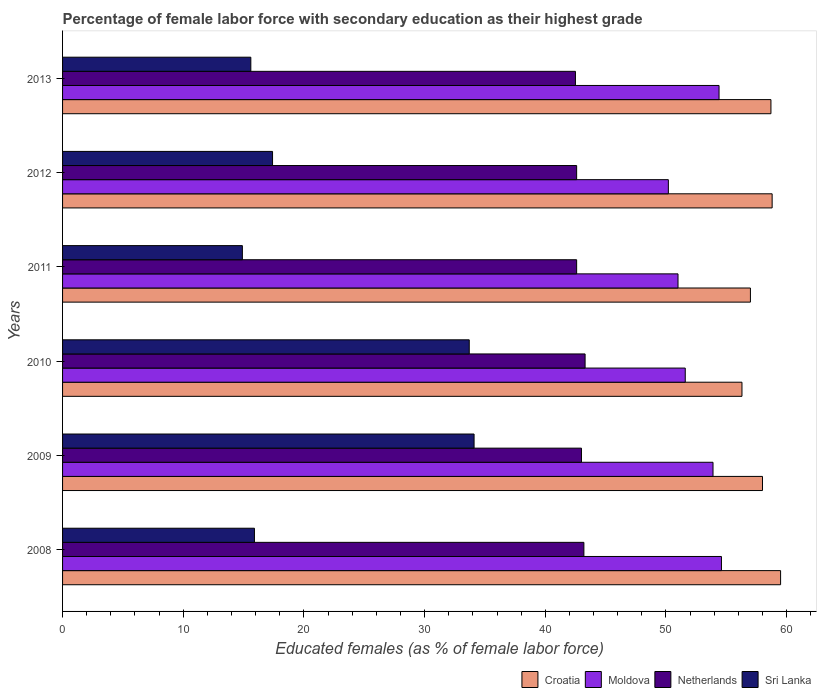Are the number of bars per tick equal to the number of legend labels?
Offer a terse response. Yes. How many bars are there on the 3rd tick from the bottom?
Provide a succinct answer. 4. In how many cases, is the number of bars for a given year not equal to the number of legend labels?
Make the answer very short. 0. What is the percentage of female labor force with secondary education in Croatia in 2013?
Ensure brevity in your answer.  58.7. Across all years, what is the maximum percentage of female labor force with secondary education in Croatia?
Offer a very short reply. 59.5. Across all years, what is the minimum percentage of female labor force with secondary education in Sri Lanka?
Your response must be concise. 14.9. In which year was the percentage of female labor force with secondary education in Sri Lanka maximum?
Offer a very short reply. 2009. In which year was the percentage of female labor force with secondary education in Sri Lanka minimum?
Ensure brevity in your answer.  2011. What is the total percentage of female labor force with secondary education in Moldova in the graph?
Your response must be concise. 315.7. What is the difference between the percentage of female labor force with secondary education in Sri Lanka in 2010 and that in 2012?
Provide a succinct answer. 16.3. What is the difference between the percentage of female labor force with secondary education in Sri Lanka in 2009 and the percentage of female labor force with secondary education in Netherlands in 2012?
Offer a terse response. -8.5. What is the average percentage of female labor force with secondary education in Sri Lanka per year?
Your response must be concise. 21.93. In the year 2010, what is the difference between the percentage of female labor force with secondary education in Moldova and percentage of female labor force with secondary education in Croatia?
Offer a very short reply. -4.7. In how many years, is the percentage of female labor force with secondary education in Moldova greater than 8 %?
Your answer should be compact. 6. What is the ratio of the percentage of female labor force with secondary education in Croatia in 2009 to that in 2011?
Ensure brevity in your answer.  1.02. Is the percentage of female labor force with secondary education in Netherlands in 2008 less than that in 2010?
Give a very brief answer. Yes. What is the difference between the highest and the second highest percentage of female labor force with secondary education in Netherlands?
Ensure brevity in your answer.  0.1. What is the difference between the highest and the lowest percentage of female labor force with secondary education in Moldova?
Your response must be concise. 4.4. Is the sum of the percentage of female labor force with secondary education in Moldova in 2012 and 2013 greater than the maximum percentage of female labor force with secondary education in Netherlands across all years?
Your answer should be compact. Yes. What does the 4th bar from the top in 2012 represents?
Your response must be concise. Croatia. What does the 4th bar from the bottom in 2013 represents?
Offer a very short reply. Sri Lanka. Are all the bars in the graph horizontal?
Offer a terse response. Yes. Are the values on the major ticks of X-axis written in scientific E-notation?
Your response must be concise. No. How many legend labels are there?
Ensure brevity in your answer.  4. What is the title of the graph?
Offer a very short reply. Percentage of female labor force with secondary education as their highest grade. Does "Palau" appear as one of the legend labels in the graph?
Keep it short and to the point. No. What is the label or title of the X-axis?
Offer a very short reply. Educated females (as % of female labor force). What is the label or title of the Y-axis?
Ensure brevity in your answer.  Years. What is the Educated females (as % of female labor force) of Croatia in 2008?
Make the answer very short. 59.5. What is the Educated females (as % of female labor force) of Moldova in 2008?
Offer a terse response. 54.6. What is the Educated females (as % of female labor force) of Netherlands in 2008?
Provide a short and direct response. 43.2. What is the Educated females (as % of female labor force) in Sri Lanka in 2008?
Offer a terse response. 15.9. What is the Educated females (as % of female labor force) of Moldova in 2009?
Provide a short and direct response. 53.9. What is the Educated females (as % of female labor force) in Netherlands in 2009?
Offer a very short reply. 43. What is the Educated females (as % of female labor force) in Sri Lanka in 2009?
Your response must be concise. 34.1. What is the Educated females (as % of female labor force) of Croatia in 2010?
Provide a short and direct response. 56.3. What is the Educated females (as % of female labor force) in Moldova in 2010?
Provide a succinct answer. 51.6. What is the Educated females (as % of female labor force) of Netherlands in 2010?
Make the answer very short. 43.3. What is the Educated females (as % of female labor force) of Sri Lanka in 2010?
Ensure brevity in your answer.  33.7. What is the Educated females (as % of female labor force) of Moldova in 2011?
Ensure brevity in your answer.  51. What is the Educated females (as % of female labor force) in Netherlands in 2011?
Give a very brief answer. 42.6. What is the Educated females (as % of female labor force) of Sri Lanka in 2011?
Offer a terse response. 14.9. What is the Educated females (as % of female labor force) of Croatia in 2012?
Your answer should be compact. 58.8. What is the Educated females (as % of female labor force) of Moldova in 2012?
Ensure brevity in your answer.  50.2. What is the Educated females (as % of female labor force) of Netherlands in 2012?
Provide a short and direct response. 42.6. What is the Educated females (as % of female labor force) of Sri Lanka in 2012?
Offer a terse response. 17.4. What is the Educated females (as % of female labor force) of Croatia in 2013?
Make the answer very short. 58.7. What is the Educated females (as % of female labor force) in Moldova in 2013?
Your answer should be compact. 54.4. What is the Educated females (as % of female labor force) in Netherlands in 2013?
Your response must be concise. 42.5. What is the Educated females (as % of female labor force) in Sri Lanka in 2013?
Offer a terse response. 15.6. Across all years, what is the maximum Educated females (as % of female labor force) in Croatia?
Make the answer very short. 59.5. Across all years, what is the maximum Educated females (as % of female labor force) in Moldova?
Keep it short and to the point. 54.6. Across all years, what is the maximum Educated females (as % of female labor force) in Netherlands?
Your response must be concise. 43.3. Across all years, what is the maximum Educated females (as % of female labor force) of Sri Lanka?
Your answer should be very brief. 34.1. Across all years, what is the minimum Educated females (as % of female labor force) of Croatia?
Your answer should be compact. 56.3. Across all years, what is the minimum Educated females (as % of female labor force) in Moldova?
Give a very brief answer. 50.2. Across all years, what is the minimum Educated females (as % of female labor force) in Netherlands?
Provide a succinct answer. 42.5. Across all years, what is the minimum Educated females (as % of female labor force) in Sri Lanka?
Your response must be concise. 14.9. What is the total Educated females (as % of female labor force) in Croatia in the graph?
Make the answer very short. 348.3. What is the total Educated females (as % of female labor force) in Moldova in the graph?
Provide a succinct answer. 315.7. What is the total Educated females (as % of female labor force) in Netherlands in the graph?
Keep it short and to the point. 257.2. What is the total Educated females (as % of female labor force) in Sri Lanka in the graph?
Give a very brief answer. 131.6. What is the difference between the Educated females (as % of female labor force) of Moldova in 2008 and that in 2009?
Your answer should be very brief. 0.7. What is the difference between the Educated females (as % of female labor force) of Sri Lanka in 2008 and that in 2009?
Your answer should be very brief. -18.2. What is the difference between the Educated females (as % of female labor force) of Croatia in 2008 and that in 2010?
Make the answer very short. 3.2. What is the difference between the Educated females (as % of female labor force) of Sri Lanka in 2008 and that in 2010?
Your answer should be compact. -17.8. What is the difference between the Educated females (as % of female labor force) in Croatia in 2008 and that in 2011?
Give a very brief answer. 2.5. What is the difference between the Educated females (as % of female labor force) of Moldova in 2008 and that in 2011?
Your answer should be very brief. 3.6. What is the difference between the Educated females (as % of female labor force) of Sri Lanka in 2008 and that in 2011?
Offer a terse response. 1. What is the difference between the Educated females (as % of female labor force) of Netherlands in 2008 and that in 2012?
Your answer should be compact. 0.6. What is the difference between the Educated females (as % of female labor force) in Moldova in 2008 and that in 2013?
Give a very brief answer. 0.2. What is the difference between the Educated females (as % of female labor force) in Netherlands in 2008 and that in 2013?
Make the answer very short. 0.7. What is the difference between the Educated females (as % of female labor force) of Croatia in 2009 and that in 2010?
Give a very brief answer. 1.7. What is the difference between the Educated females (as % of female labor force) in Sri Lanka in 2009 and that in 2010?
Your answer should be very brief. 0.4. What is the difference between the Educated females (as % of female labor force) in Croatia in 2009 and that in 2011?
Keep it short and to the point. 1. What is the difference between the Educated females (as % of female labor force) of Netherlands in 2009 and that in 2011?
Make the answer very short. 0.4. What is the difference between the Educated females (as % of female labor force) of Sri Lanka in 2009 and that in 2011?
Offer a terse response. 19.2. What is the difference between the Educated females (as % of female labor force) of Croatia in 2009 and that in 2012?
Provide a succinct answer. -0.8. What is the difference between the Educated females (as % of female labor force) in Netherlands in 2009 and that in 2012?
Make the answer very short. 0.4. What is the difference between the Educated females (as % of female labor force) in Sri Lanka in 2009 and that in 2012?
Offer a terse response. 16.7. What is the difference between the Educated females (as % of female labor force) of Croatia in 2009 and that in 2013?
Your answer should be very brief. -0.7. What is the difference between the Educated females (as % of female labor force) in Sri Lanka in 2009 and that in 2013?
Your answer should be compact. 18.5. What is the difference between the Educated females (as % of female labor force) in Croatia in 2010 and that in 2011?
Your answer should be very brief. -0.7. What is the difference between the Educated females (as % of female labor force) of Sri Lanka in 2010 and that in 2011?
Keep it short and to the point. 18.8. What is the difference between the Educated females (as % of female labor force) of Croatia in 2010 and that in 2012?
Your response must be concise. -2.5. What is the difference between the Educated females (as % of female labor force) in Moldova in 2010 and that in 2012?
Provide a succinct answer. 1.4. What is the difference between the Educated females (as % of female labor force) in Moldova in 2010 and that in 2013?
Your response must be concise. -2.8. What is the difference between the Educated females (as % of female labor force) in Croatia in 2011 and that in 2012?
Provide a short and direct response. -1.8. What is the difference between the Educated females (as % of female labor force) of Moldova in 2011 and that in 2012?
Your answer should be very brief. 0.8. What is the difference between the Educated females (as % of female labor force) in Netherlands in 2011 and that in 2012?
Provide a succinct answer. 0. What is the difference between the Educated females (as % of female labor force) in Sri Lanka in 2011 and that in 2012?
Give a very brief answer. -2.5. What is the difference between the Educated females (as % of female labor force) of Moldova in 2011 and that in 2013?
Provide a succinct answer. -3.4. What is the difference between the Educated females (as % of female labor force) of Netherlands in 2011 and that in 2013?
Provide a short and direct response. 0.1. What is the difference between the Educated females (as % of female labor force) of Sri Lanka in 2011 and that in 2013?
Make the answer very short. -0.7. What is the difference between the Educated females (as % of female labor force) of Croatia in 2012 and that in 2013?
Your answer should be compact. 0.1. What is the difference between the Educated females (as % of female labor force) of Netherlands in 2012 and that in 2013?
Your response must be concise. 0.1. What is the difference between the Educated females (as % of female labor force) of Sri Lanka in 2012 and that in 2013?
Offer a terse response. 1.8. What is the difference between the Educated females (as % of female labor force) in Croatia in 2008 and the Educated females (as % of female labor force) in Moldova in 2009?
Ensure brevity in your answer.  5.6. What is the difference between the Educated females (as % of female labor force) in Croatia in 2008 and the Educated females (as % of female labor force) in Netherlands in 2009?
Keep it short and to the point. 16.5. What is the difference between the Educated females (as % of female labor force) in Croatia in 2008 and the Educated females (as % of female labor force) in Sri Lanka in 2009?
Offer a very short reply. 25.4. What is the difference between the Educated females (as % of female labor force) of Moldova in 2008 and the Educated females (as % of female labor force) of Sri Lanka in 2009?
Give a very brief answer. 20.5. What is the difference between the Educated females (as % of female labor force) in Croatia in 2008 and the Educated females (as % of female labor force) in Sri Lanka in 2010?
Offer a very short reply. 25.8. What is the difference between the Educated females (as % of female labor force) of Moldova in 2008 and the Educated females (as % of female labor force) of Netherlands in 2010?
Your answer should be very brief. 11.3. What is the difference between the Educated females (as % of female labor force) of Moldova in 2008 and the Educated females (as % of female labor force) of Sri Lanka in 2010?
Your response must be concise. 20.9. What is the difference between the Educated females (as % of female labor force) of Netherlands in 2008 and the Educated females (as % of female labor force) of Sri Lanka in 2010?
Offer a terse response. 9.5. What is the difference between the Educated females (as % of female labor force) of Croatia in 2008 and the Educated females (as % of female labor force) of Sri Lanka in 2011?
Offer a very short reply. 44.6. What is the difference between the Educated females (as % of female labor force) of Moldova in 2008 and the Educated females (as % of female labor force) of Sri Lanka in 2011?
Your response must be concise. 39.7. What is the difference between the Educated females (as % of female labor force) in Netherlands in 2008 and the Educated females (as % of female labor force) in Sri Lanka in 2011?
Make the answer very short. 28.3. What is the difference between the Educated females (as % of female labor force) of Croatia in 2008 and the Educated females (as % of female labor force) of Sri Lanka in 2012?
Provide a succinct answer. 42.1. What is the difference between the Educated females (as % of female labor force) in Moldova in 2008 and the Educated females (as % of female labor force) in Sri Lanka in 2012?
Your response must be concise. 37.2. What is the difference between the Educated females (as % of female labor force) in Netherlands in 2008 and the Educated females (as % of female labor force) in Sri Lanka in 2012?
Provide a short and direct response. 25.8. What is the difference between the Educated females (as % of female labor force) in Croatia in 2008 and the Educated females (as % of female labor force) in Moldova in 2013?
Offer a very short reply. 5.1. What is the difference between the Educated females (as % of female labor force) of Croatia in 2008 and the Educated females (as % of female labor force) of Sri Lanka in 2013?
Provide a short and direct response. 43.9. What is the difference between the Educated females (as % of female labor force) of Moldova in 2008 and the Educated females (as % of female labor force) of Netherlands in 2013?
Give a very brief answer. 12.1. What is the difference between the Educated females (as % of female labor force) of Moldova in 2008 and the Educated females (as % of female labor force) of Sri Lanka in 2013?
Your answer should be compact. 39. What is the difference between the Educated females (as % of female labor force) in Netherlands in 2008 and the Educated females (as % of female labor force) in Sri Lanka in 2013?
Your response must be concise. 27.6. What is the difference between the Educated females (as % of female labor force) of Croatia in 2009 and the Educated females (as % of female labor force) of Sri Lanka in 2010?
Ensure brevity in your answer.  24.3. What is the difference between the Educated females (as % of female labor force) of Moldova in 2009 and the Educated females (as % of female labor force) of Sri Lanka in 2010?
Make the answer very short. 20.2. What is the difference between the Educated females (as % of female labor force) of Netherlands in 2009 and the Educated females (as % of female labor force) of Sri Lanka in 2010?
Offer a terse response. 9.3. What is the difference between the Educated females (as % of female labor force) of Croatia in 2009 and the Educated females (as % of female labor force) of Sri Lanka in 2011?
Provide a short and direct response. 43.1. What is the difference between the Educated females (as % of female labor force) of Netherlands in 2009 and the Educated females (as % of female labor force) of Sri Lanka in 2011?
Keep it short and to the point. 28.1. What is the difference between the Educated females (as % of female labor force) of Croatia in 2009 and the Educated females (as % of female labor force) of Netherlands in 2012?
Give a very brief answer. 15.4. What is the difference between the Educated females (as % of female labor force) of Croatia in 2009 and the Educated females (as % of female labor force) of Sri Lanka in 2012?
Offer a terse response. 40.6. What is the difference between the Educated females (as % of female labor force) in Moldova in 2009 and the Educated females (as % of female labor force) in Netherlands in 2012?
Provide a short and direct response. 11.3. What is the difference between the Educated females (as % of female labor force) in Moldova in 2009 and the Educated females (as % of female labor force) in Sri Lanka in 2012?
Offer a terse response. 36.5. What is the difference between the Educated females (as % of female labor force) of Netherlands in 2009 and the Educated females (as % of female labor force) of Sri Lanka in 2012?
Provide a succinct answer. 25.6. What is the difference between the Educated females (as % of female labor force) in Croatia in 2009 and the Educated females (as % of female labor force) in Moldova in 2013?
Give a very brief answer. 3.6. What is the difference between the Educated females (as % of female labor force) of Croatia in 2009 and the Educated females (as % of female labor force) of Netherlands in 2013?
Your response must be concise. 15.5. What is the difference between the Educated females (as % of female labor force) of Croatia in 2009 and the Educated females (as % of female labor force) of Sri Lanka in 2013?
Your answer should be very brief. 42.4. What is the difference between the Educated females (as % of female labor force) in Moldova in 2009 and the Educated females (as % of female labor force) in Netherlands in 2013?
Offer a terse response. 11.4. What is the difference between the Educated females (as % of female labor force) in Moldova in 2009 and the Educated females (as % of female labor force) in Sri Lanka in 2013?
Provide a succinct answer. 38.3. What is the difference between the Educated females (as % of female labor force) in Netherlands in 2009 and the Educated females (as % of female labor force) in Sri Lanka in 2013?
Your response must be concise. 27.4. What is the difference between the Educated females (as % of female labor force) in Croatia in 2010 and the Educated females (as % of female labor force) in Moldova in 2011?
Keep it short and to the point. 5.3. What is the difference between the Educated females (as % of female labor force) in Croatia in 2010 and the Educated females (as % of female labor force) in Netherlands in 2011?
Make the answer very short. 13.7. What is the difference between the Educated females (as % of female labor force) in Croatia in 2010 and the Educated females (as % of female labor force) in Sri Lanka in 2011?
Provide a short and direct response. 41.4. What is the difference between the Educated females (as % of female labor force) in Moldova in 2010 and the Educated females (as % of female labor force) in Sri Lanka in 2011?
Ensure brevity in your answer.  36.7. What is the difference between the Educated females (as % of female labor force) of Netherlands in 2010 and the Educated females (as % of female labor force) of Sri Lanka in 2011?
Provide a short and direct response. 28.4. What is the difference between the Educated females (as % of female labor force) in Croatia in 2010 and the Educated females (as % of female labor force) in Sri Lanka in 2012?
Provide a succinct answer. 38.9. What is the difference between the Educated females (as % of female labor force) in Moldova in 2010 and the Educated females (as % of female labor force) in Sri Lanka in 2012?
Ensure brevity in your answer.  34.2. What is the difference between the Educated females (as % of female labor force) in Netherlands in 2010 and the Educated females (as % of female labor force) in Sri Lanka in 2012?
Provide a short and direct response. 25.9. What is the difference between the Educated females (as % of female labor force) in Croatia in 2010 and the Educated females (as % of female labor force) in Sri Lanka in 2013?
Provide a short and direct response. 40.7. What is the difference between the Educated females (as % of female labor force) in Moldova in 2010 and the Educated females (as % of female labor force) in Netherlands in 2013?
Ensure brevity in your answer.  9.1. What is the difference between the Educated females (as % of female labor force) of Moldova in 2010 and the Educated females (as % of female labor force) of Sri Lanka in 2013?
Offer a terse response. 36. What is the difference between the Educated females (as % of female labor force) in Netherlands in 2010 and the Educated females (as % of female labor force) in Sri Lanka in 2013?
Give a very brief answer. 27.7. What is the difference between the Educated females (as % of female labor force) of Croatia in 2011 and the Educated females (as % of female labor force) of Netherlands in 2012?
Offer a terse response. 14.4. What is the difference between the Educated females (as % of female labor force) in Croatia in 2011 and the Educated females (as % of female labor force) in Sri Lanka in 2012?
Your answer should be compact. 39.6. What is the difference between the Educated females (as % of female labor force) of Moldova in 2011 and the Educated females (as % of female labor force) of Netherlands in 2012?
Offer a very short reply. 8.4. What is the difference between the Educated females (as % of female labor force) of Moldova in 2011 and the Educated females (as % of female labor force) of Sri Lanka in 2012?
Make the answer very short. 33.6. What is the difference between the Educated females (as % of female labor force) of Netherlands in 2011 and the Educated females (as % of female labor force) of Sri Lanka in 2012?
Give a very brief answer. 25.2. What is the difference between the Educated females (as % of female labor force) of Croatia in 2011 and the Educated females (as % of female labor force) of Sri Lanka in 2013?
Your answer should be compact. 41.4. What is the difference between the Educated females (as % of female labor force) of Moldova in 2011 and the Educated females (as % of female labor force) of Sri Lanka in 2013?
Your response must be concise. 35.4. What is the difference between the Educated females (as % of female labor force) of Netherlands in 2011 and the Educated females (as % of female labor force) of Sri Lanka in 2013?
Offer a terse response. 27. What is the difference between the Educated females (as % of female labor force) of Croatia in 2012 and the Educated females (as % of female labor force) of Netherlands in 2013?
Offer a very short reply. 16.3. What is the difference between the Educated females (as % of female labor force) in Croatia in 2012 and the Educated females (as % of female labor force) in Sri Lanka in 2013?
Ensure brevity in your answer.  43.2. What is the difference between the Educated females (as % of female labor force) in Moldova in 2012 and the Educated females (as % of female labor force) in Netherlands in 2013?
Keep it short and to the point. 7.7. What is the difference between the Educated females (as % of female labor force) in Moldova in 2012 and the Educated females (as % of female labor force) in Sri Lanka in 2013?
Your response must be concise. 34.6. What is the average Educated females (as % of female labor force) in Croatia per year?
Keep it short and to the point. 58.05. What is the average Educated females (as % of female labor force) in Moldova per year?
Offer a terse response. 52.62. What is the average Educated females (as % of female labor force) in Netherlands per year?
Your answer should be very brief. 42.87. What is the average Educated females (as % of female labor force) in Sri Lanka per year?
Give a very brief answer. 21.93. In the year 2008, what is the difference between the Educated females (as % of female labor force) in Croatia and Educated females (as % of female labor force) in Moldova?
Offer a very short reply. 4.9. In the year 2008, what is the difference between the Educated females (as % of female labor force) in Croatia and Educated females (as % of female labor force) in Sri Lanka?
Your answer should be compact. 43.6. In the year 2008, what is the difference between the Educated females (as % of female labor force) in Moldova and Educated females (as % of female labor force) in Netherlands?
Your answer should be very brief. 11.4. In the year 2008, what is the difference between the Educated females (as % of female labor force) of Moldova and Educated females (as % of female labor force) of Sri Lanka?
Provide a succinct answer. 38.7. In the year 2008, what is the difference between the Educated females (as % of female labor force) in Netherlands and Educated females (as % of female labor force) in Sri Lanka?
Make the answer very short. 27.3. In the year 2009, what is the difference between the Educated females (as % of female labor force) of Croatia and Educated females (as % of female labor force) of Netherlands?
Provide a succinct answer. 15. In the year 2009, what is the difference between the Educated females (as % of female labor force) of Croatia and Educated females (as % of female labor force) of Sri Lanka?
Provide a succinct answer. 23.9. In the year 2009, what is the difference between the Educated females (as % of female labor force) of Moldova and Educated females (as % of female labor force) of Netherlands?
Make the answer very short. 10.9. In the year 2009, what is the difference between the Educated females (as % of female labor force) of Moldova and Educated females (as % of female labor force) of Sri Lanka?
Your answer should be compact. 19.8. In the year 2010, what is the difference between the Educated females (as % of female labor force) of Croatia and Educated females (as % of female labor force) of Sri Lanka?
Provide a succinct answer. 22.6. In the year 2010, what is the difference between the Educated females (as % of female labor force) in Moldova and Educated females (as % of female labor force) in Netherlands?
Offer a terse response. 8.3. In the year 2011, what is the difference between the Educated females (as % of female labor force) in Croatia and Educated females (as % of female labor force) in Moldova?
Ensure brevity in your answer.  6. In the year 2011, what is the difference between the Educated females (as % of female labor force) of Croatia and Educated females (as % of female labor force) of Sri Lanka?
Make the answer very short. 42.1. In the year 2011, what is the difference between the Educated females (as % of female labor force) of Moldova and Educated females (as % of female labor force) of Netherlands?
Provide a succinct answer. 8.4. In the year 2011, what is the difference between the Educated females (as % of female labor force) in Moldova and Educated females (as % of female labor force) in Sri Lanka?
Give a very brief answer. 36.1. In the year 2011, what is the difference between the Educated females (as % of female labor force) in Netherlands and Educated females (as % of female labor force) in Sri Lanka?
Offer a terse response. 27.7. In the year 2012, what is the difference between the Educated females (as % of female labor force) in Croatia and Educated females (as % of female labor force) in Moldova?
Keep it short and to the point. 8.6. In the year 2012, what is the difference between the Educated females (as % of female labor force) of Croatia and Educated females (as % of female labor force) of Sri Lanka?
Your answer should be compact. 41.4. In the year 2012, what is the difference between the Educated females (as % of female labor force) of Moldova and Educated females (as % of female labor force) of Sri Lanka?
Keep it short and to the point. 32.8. In the year 2012, what is the difference between the Educated females (as % of female labor force) of Netherlands and Educated females (as % of female labor force) of Sri Lanka?
Your response must be concise. 25.2. In the year 2013, what is the difference between the Educated females (as % of female labor force) in Croatia and Educated females (as % of female labor force) in Moldova?
Offer a terse response. 4.3. In the year 2013, what is the difference between the Educated females (as % of female labor force) of Croatia and Educated females (as % of female labor force) of Netherlands?
Offer a very short reply. 16.2. In the year 2013, what is the difference between the Educated females (as % of female labor force) of Croatia and Educated females (as % of female labor force) of Sri Lanka?
Make the answer very short. 43.1. In the year 2013, what is the difference between the Educated females (as % of female labor force) of Moldova and Educated females (as % of female labor force) of Sri Lanka?
Provide a short and direct response. 38.8. In the year 2013, what is the difference between the Educated females (as % of female labor force) of Netherlands and Educated females (as % of female labor force) of Sri Lanka?
Provide a succinct answer. 26.9. What is the ratio of the Educated females (as % of female labor force) in Croatia in 2008 to that in 2009?
Your response must be concise. 1.03. What is the ratio of the Educated females (as % of female labor force) in Moldova in 2008 to that in 2009?
Make the answer very short. 1.01. What is the ratio of the Educated females (as % of female labor force) in Sri Lanka in 2008 to that in 2009?
Give a very brief answer. 0.47. What is the ratio of the Educated females (as % of female labor force) of Croatia in 2008 to that in 2010?
Your answer should be very brief. 1.06. What is the ratio of the Educated females (as % of female labor force) of Moldova in 2008 to that in 2010?
Give a very brief answer. 1.06. What is the ratio of the Educated females (as % of female labor force) of Sri Lanka in 2008 to that in 2010?
Make the answer very short. 0.47. What is the ratio of the Educated females (as % of female labor force) of Croatia in 2008 to that in 2011?
Offer a terse response. 1.04. What is the ratio of the Educated females (as % of female labor force) in Moldova in 2008 to that in 2011?
Keep it short and to the point. 1.07. What is the ratio of the Educated females (as % of female labor force) in Netherlands in 2008 to that in 2011?
Offer a terse response. 1.01. What is the ratio of the Educated females (as % of female labor force) in Sri Lanka in 2008 to that in 2011?
Provide a succinct answer. 1.07. What is the ratio of the Educated females (as % of female labor force) in Croatia in 2008 to that in 2012?
Offer a very short reply. 1.01. What is the ratio of the Educated females (as % of female labor force) in Moldova in 2008 to that in 2012?
Keep it short and to the point. 1.09. What is the ratio of the Educated females (as % of female labor force) in Netherlands in 2008 to that in 2012?
Provide a succinct answer. 1.01. What is the ratio of the Educated females (as % of female labor force) of Sri Lanka in 2008 to that in 2012?
Offer a terse response. 0.91. What is the ratio of the Educated females (as % of female labor force) of Croatia in 2008 to that in 2013?
Your answer should be very brief. 1.01. What is the ratio of the Educated females (as % of female labor force) of Netherlands in 2008 to that in 2013?
Make the answer very short. 1.02. What is the ratio of the Educated females (as % of female labor force) of Sri Lanka in 2008 to that in 2013?
Your response must be concise. 1.02. What is the ratio of the Educated females (as % of female labor force) in Croatia in 2009 to that in 2010?
Offer a very short reply. 1.03. What is the ratio of the Educated females (as % of female labor force) of Moldova in 2009 to that in 2010?
Your response must be concise. 1.04. What is the ratio of the Educated females (as % of female labor force) in Netherlands in 2009 to that in 2010?
Your response must be concise. 0.99. What is the ratio of the Educated females (as % of female labor force) of Sri Lanka in 2009 to that in 2010?
Make the answer very short. 1.01. What is the ratio of the Educated females (as % of female labor force) in Croatia in 2009 to that in 2011?
Offer a very short reply. 1.02. What is the ratio of the Educated females (as % of female labor force) of Moldova in 2009 to that in 2011?
Provide a succinct answer. 1.06. What is the ratio of the Educated females (as % of female labor force) of Netherlands in 2009 to that in 2011?
Keep it short and to the point. 1.01. What is the ratio of the Educated females (as % of female labor force) of Sri Lanka in 2009 to that in 2011?
Offer a terse response. 2.29. What is the ratio of the Educated females (as % of female labor force) in Croatia in 2009 to that in 2012?
Provide a short and direct response. 0.99. What is the ratio of the Educated females (as % of female labor force) of Moldova in 2009 to that in 2012?
Keep it short and to the point. 1.07. What is the ratio of the Educated females (as % of female labor force) in Netherlands in 2009 to that in 2012?
Give a very brief answer. 1.01. What is the ratio of the Educated females (as % of female labor force) in Sri Lanka in 2009 to that in 2012?
Your answer should be very brief. 1.96. What is the ratio of the Educated females (as % of female labor force) of Croatia in 2009 to that in 2013?
Your answer should be compact. 0.99. What is the ratio of the Educated females (as % of female labor force) in Netherlands in 2009 to that in 2013?
Provide a succinct answer. 1.01. What is the ratio of the Educated females (as % of female labor force) in Sri Lanka in 2009 to that in 2013?
Make the answer very short. 2.19. What is the ratio of the Educated females (as % of female labor force) in Croatia in 2010 to that in 2011?
Keep it short and to the point. 0.99. What is the ratio of the Educated females (as % of female labor force) in Moldova in 2010 to that in 2011?
Make the answer very short. 1.01. What is the ratio of the Educated females (as % of female labor force) in Netherlands in 2010 to that in 2011?
Ensure brevity in your answer.  1.02. What is the ratio of the Educated females (as % of female labor force) of Sri Lanka in 2010 to that in 2011?
Offer a terse response. 2.26. What is the ratio of the Educated females (as % of female labor force) of Croatia in 2010 to that in 2012?
Your answer should be compact. 0.96. What is the ratio of the Educated females (as % of female labor force) in Moldova in 2010 to that in 2012?
Your answer should be compact. 1.03. What is the ratio of the Educated females (as % of female labor force) of Netherlands in 2010 to that in 2012?
Your response must be concise. 1.02. What is the ratio of the Educated females (as % of female labor force) of Sri Lanka in 2010 to that in 2012?
Your answer should be compact. 1.94. What is the ratio of the Educated females (as % of female labor force) of Croatia in 2010 to that in 2013?
Make the answer very short. 0.96. What is the ratio of the Educated females (as % of female labor force) in Moldova in 2010 to that in 2013?
Provide a succinct answer. 0.95. What is the ratio of the Educated females (as % of female labor force) of Netherlands in 2010 to that in 2013?
Provide a short and direct response. 1.02. What is the ratio of the Educated females (as % of female labor force) of Sri Lanka in 2010 to that in 2013?
Ensure brevity in your answer.  2.16. What is the ratio of the Educated females (as % of female labor force) of Croatia in 2011 to that in 2012?
Ensure brevity in your answer.  0.97. What is the ratio of the Educated females (as % of female labor force) of Moldova in 2011 to that in 2012?
Provide a short and direct response. 1.02. What is the ratio of the Educated females (as % of female labor force) in Sri Lanka in 2011 to that in 2012?
Your response must be concise. 0.86. What is the ratio of the Educated females (as % of female labor force) in Croatia in 2011 to that in 2013?
Your answer should be very brief. 0.97. What is the ratio of the Educated females (as % of female labor force) in Sri Lanka in 2011 to that in 2013?
Keep it short and to the point. 0.96. What is the ratio of the Educated females (as % of female labor force) in Croatia in 2012 to that in 2013?
Offer a very short reply. 1. What is the ratio of the Educated females (as % of female labor force) in Moldova in 2012 to that in 2013?
Make the answer very short. 0.92. What is the ratio of the Educated females (as % of female labor force) of Sri Lanka in 2012 to that in 2013?
Offer a terse response. 1.12. What is the difference between the highest and the second highest Educated females (as % of female labor force) of Croatia?
Keep it short and to the point. 0.7. What is the difference between the highest and the lowest Educated females (as % of female labor force) in Moldova?
Your answer should be very brief. 4.4. 